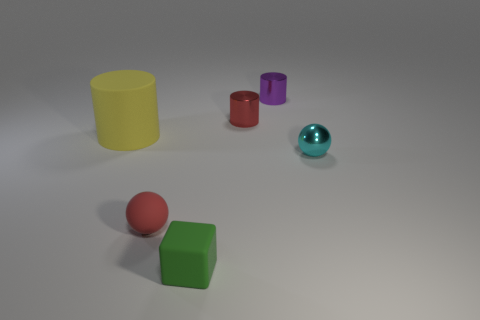Add 3 matte spheres. How many objects exist? 9 Subtract all balls. How many objects are left? 4 Subtract 0 green spheres. How many objects are left? 6 Subtract all big cylinders. Subtract all tiny cyan spheres. How many objects are left? 4 Add 6 metallic cylinders. How many metallic cylinders are left? 8 Add 3 small red cylinders. How many small red cylinders exist? 4 